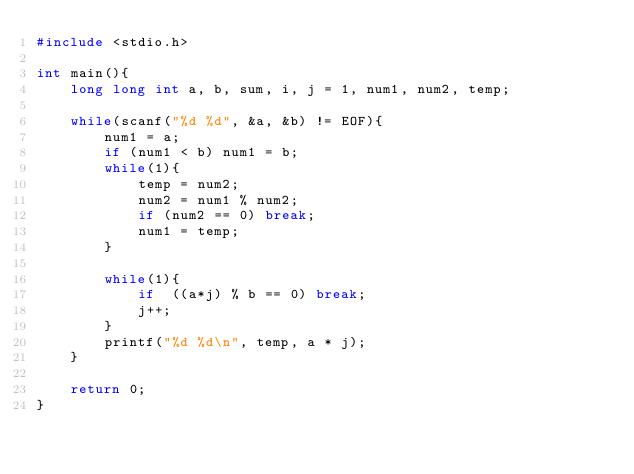<code> <loc_0><loc_0><loc_500><loc_500><_C_>#include <stdio.h>

int main(){
    long long int a, b, sum, i, j = 1, num1, num2, temp;
    
    while(scanf("%d %d", &a, &b) != EOF){
    	num1 = a;
    	if (num1 < b) num1 = b;
    	while(1){
    		temp = num2;
    	    num2 = num1 % num2;
    	    if (num2 == 0) break;
    	    num1 = temp;
    	}
        
        while(1){
            if  ((a*j) % b == 0) break;
            j++;
        }
        printf("%d %d\n", temp, a * j);
    }
    
    return 0;
}</code> 